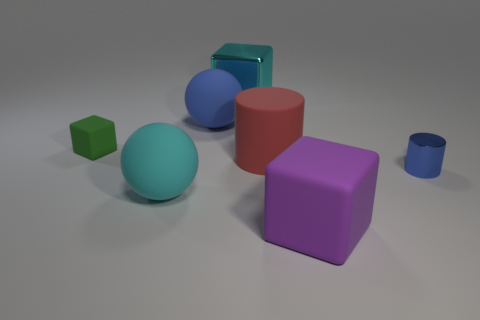Can you describe the lighting in this scene? The scene is lit with a soft, diffused light source that casts gentle shadows on the ground. There's no harsh light, and the reflections on the objects suggest that the light may be coming from above. Does the image feel more artistic or functional? The image has an artistic quality due to the composition and the simple yet pleasing arrangement of shapes and colors. However, it could also serve a functional purpose, such as being part of a graphical representation for educational purposes or a test for 3D modeling. 